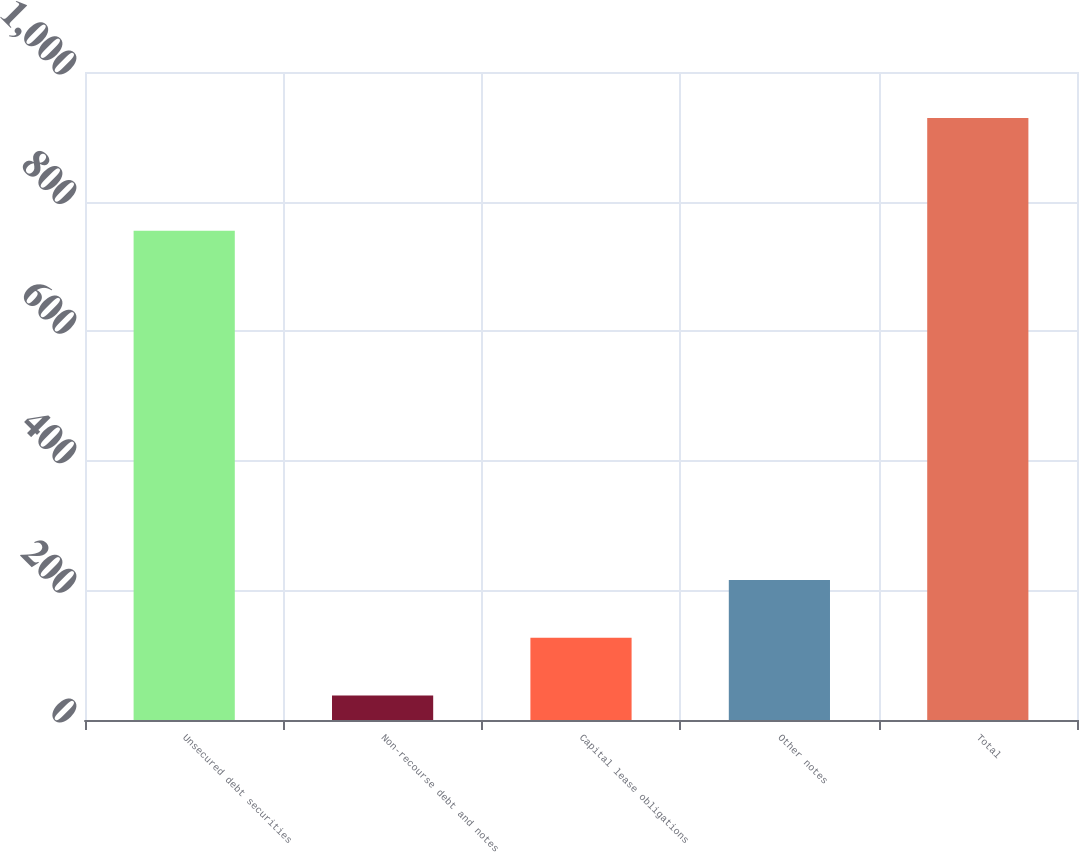<chart> <loc_0><loc_0><loc_500><loc_500><bar_chart><fcel>Unsecured debt securities<fcel>Non-recourse debt and notes<fcel>Capital lease obligations<fcel>Other notes<fcel>Total<nl><fcel>755<fcel>38<fcel>127.1<fcel>216.2<fcel>929<nl></chart> 